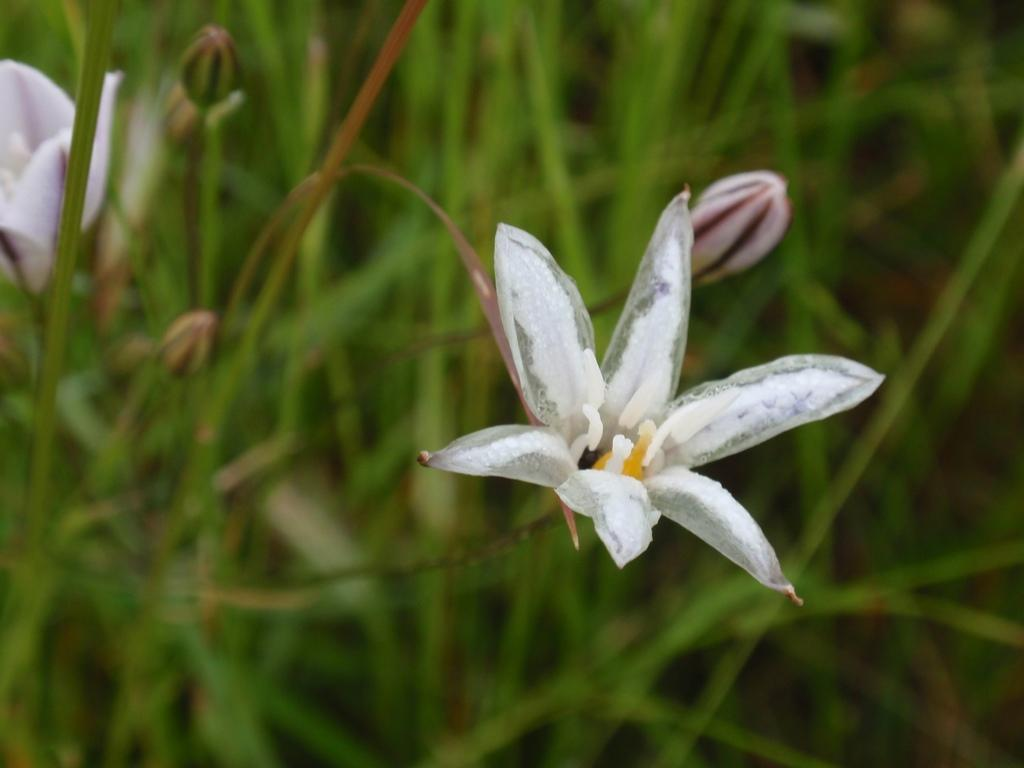What type of living organisms can be seen in the image? Flowers, buds, and plants can be seen in the image. What stage of growth are some of the plants in the image? Some of the plants in the image are in the bud stage. Can you describe the overall theme or subject of the image? The image features flowers, buds, and plants, suggesting a focus on nature or gardening. What type of leather material is visible in the image? There is no leather material present in the image. How many dimes can be seen on the plants in the image? There are no dimes present in the image; it features flowers, buds, and plants. 